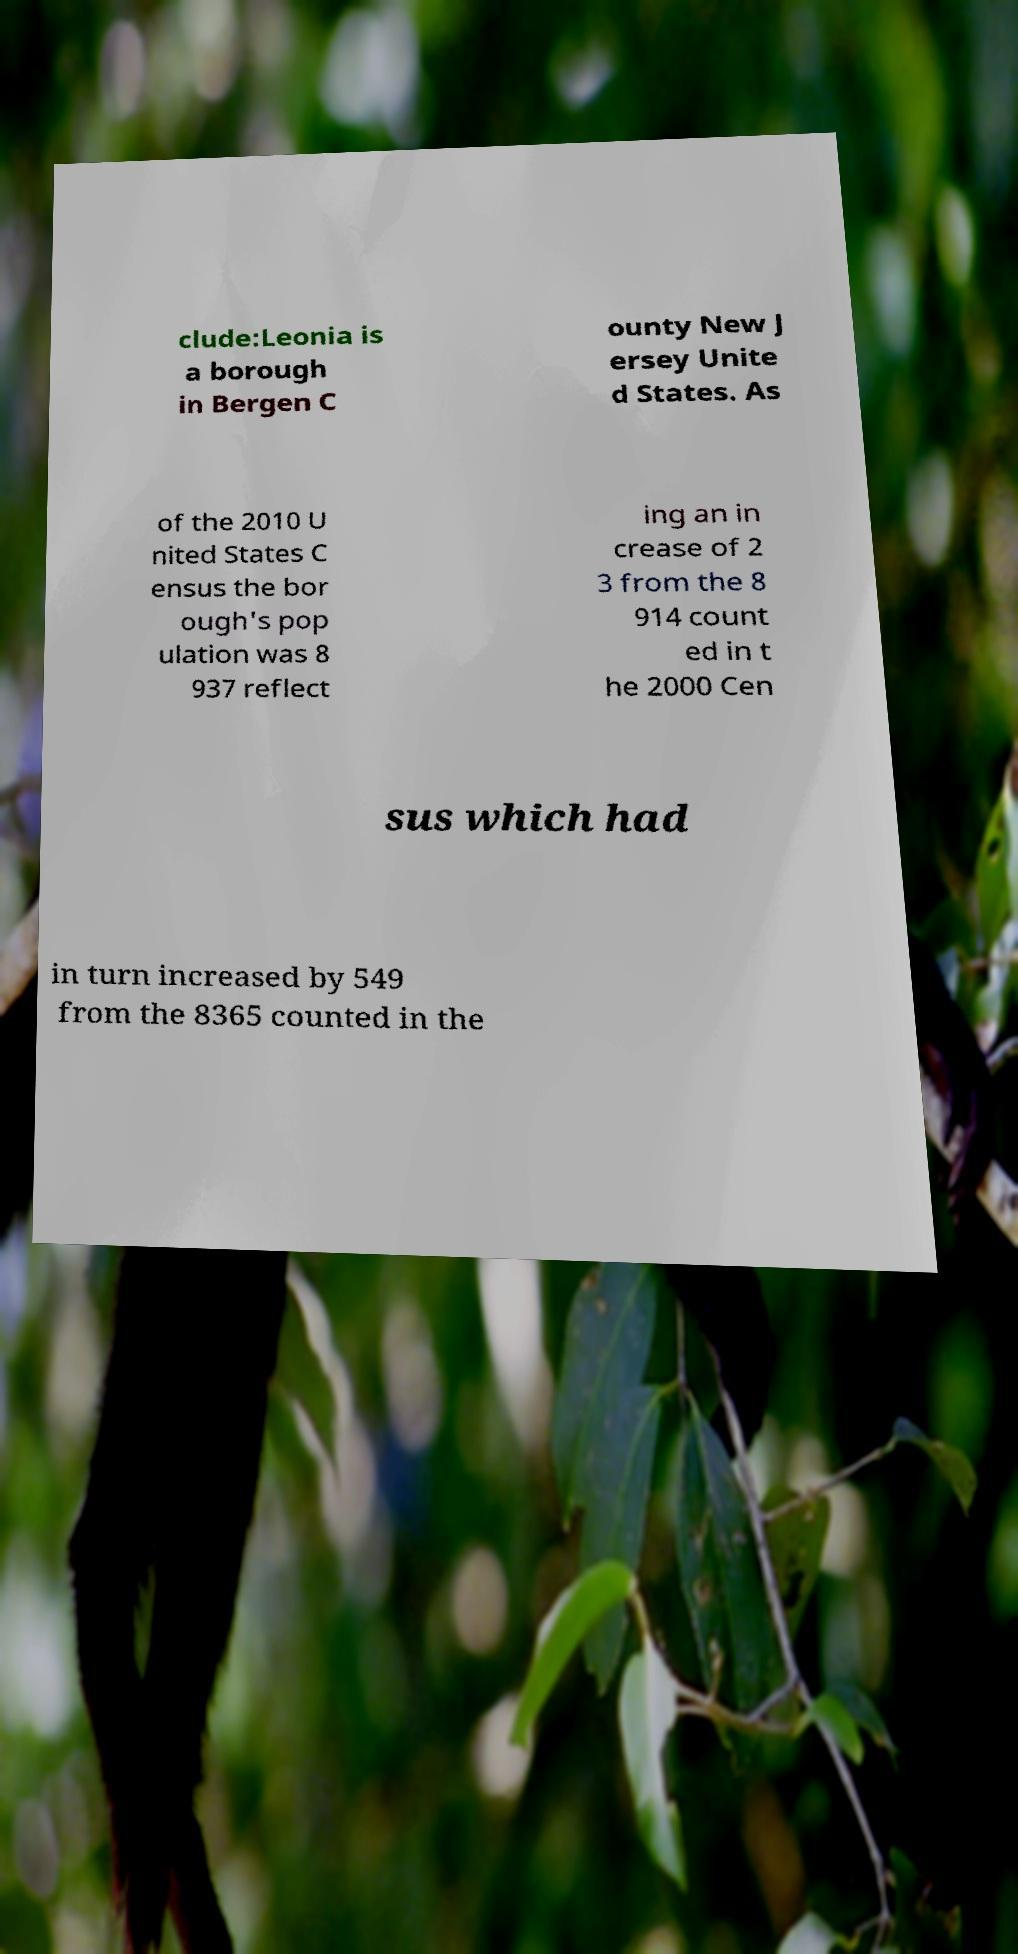There's text embedded in this image that I need extracted. Can you transcribe it verbatim? clude:Leonia is a borough in Bergen C ounty New J ersey Unite d States. As of the 2010 U nited States C ensus the bor ough's pop ulation was 8 937 reflect ing an in crease of 2 3 from the 8 914 count ed in t he 2000 Cen sus which had in turn increased by 549 from the 8365 counted in the 